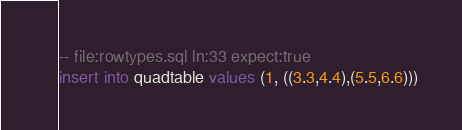<code> <loc_0><loc_0><loc_500><loc_500><_SQL_>-- file:rowtypes.sql ln:33 expect:true
insert into quadtable values (1, ((3.3,4.4),(5.5,6.6)))
</code> 